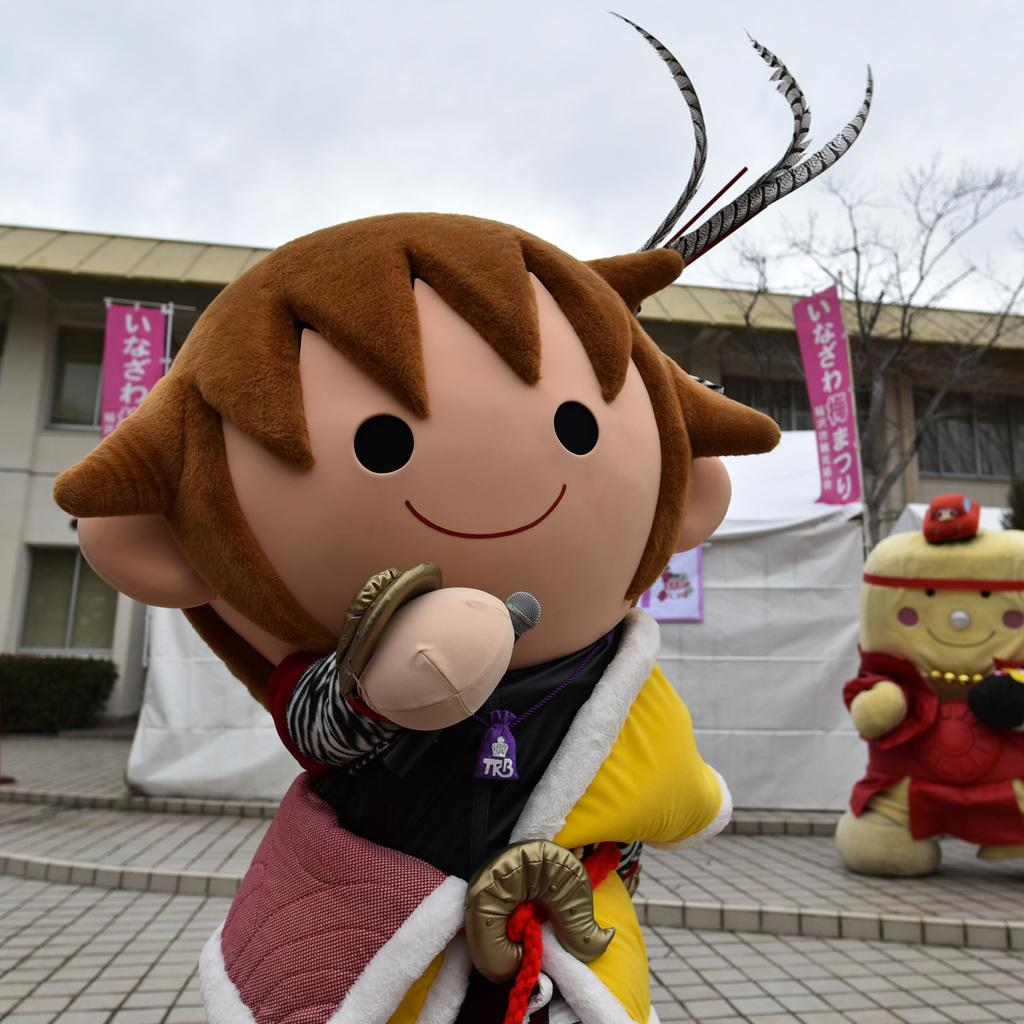What are the people in the image wearing on their faces? The humans in the image are wearing masks. What is the person holding in the image? There is a human holding a microphone in the image. What color is the cloth in the image? The cloth in the image is white. What type of structure can be seen in the image? There is a building in the image. What type of plant is visible in the image? There is a tree in the image. What is the weather like in the image? The sky is cloudy in the image. What type of tramp can be seen jumping in the image? There is no tramp present in the image. What type of structure is being copied by the humans in the image? The humans in the image are not copying any structure; they are wearing masks and holding a microphone. 